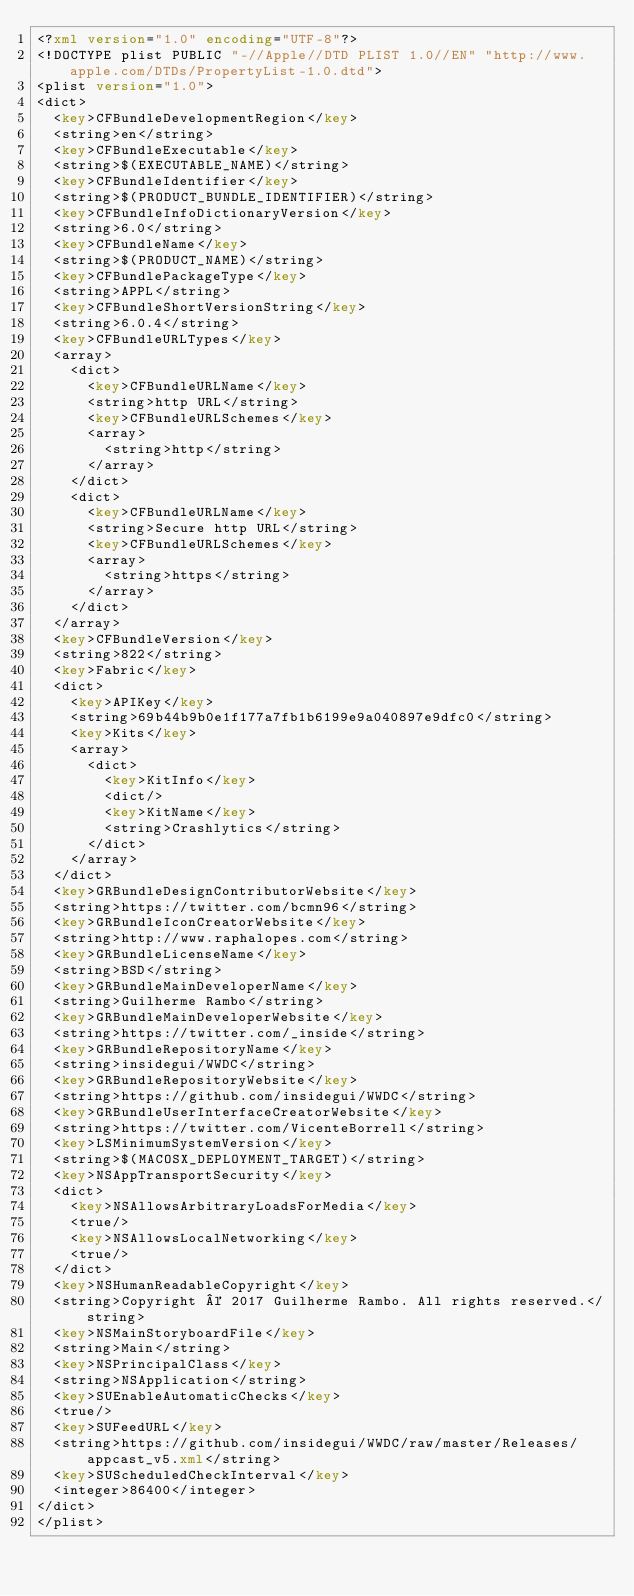<code> <loc_0><loc_0><loc_500><loc_500><_XML_><?xml version="1.0" encoding="UTF-8"?>
<!DOCTYPE plist PUBLIC "-//Apple//DTD PLIST 1.0//EN" "http://www.apple.com/DTDs/PropertyList-1.0.dtd">
<plist version="1.0">
<dict>
	<key>CFBundleDevelopmentRegion</key>
	<string>en</string>
	<key>CFBundleExecutable</key>
	<string>$(EXECUTABLE_NAME)</string>
	<key>CFBundleIdentifier</key>
	<string>$(PRODUCT_BUNDLE_IDENTIFIER)</string>
	<key>CFBundleInfoDictionaryVersion</key>
	<string>6.0</string>
	<key>CFBundleName</key>
	<string>$(PRODUCT_NAME)</string>
	<key>CFBundlePackageType</key>
	<string>APPL</string>
	<key>CFBundleShortVersionString</key>
	<string>6.0.4</string>
	<key>CFBundleURLTypes</key>
	<array>
		<dict>
			<key>CFBundleURLName</key>
			<string>http URL</string>
			<key>CFBundleURLSchemes</key>
			<array>
				<string>http</string>
			</array>
		</dict>
		<dict>
			<key>CFBundleURLName</key>
			<string>Secure http URL</string>
			<key>CFBundleURLSchemes</key>
			<array>
				<string>https</string>
			</array>
		</dict>
	</array>
	<key>CFBundleVersion</key>
	<string>822</string>
	<key>Fabric</key>
	<dict>
		<key>APIKey</key>
		<string>69b44b9b0e1f177a7fb1b6199e9a040897e9dfc0</string>
		<key>Kits</key>
		<array>
			<dict>
				<key>KitInfo</key>
				<dict/>
				<key>KitName</key>
				<string>Crashlytics</string>
			</dict>
		</array>
	</dict>
	<key>GRBundleDesignContributorWebsite</key>
	<string>https://twitter.com/bcmn96</string>
	<key>GRBundleIconCreatorWebsite</key>
	<string>http://www.raphalopes.com</string>
	<key>GRBundleLicenseName</key>
	<string>BSD</string>
	<key>GRBundleMainDeveloperName</key>
	<string>Guilherme Rambo</string>
	<key>GRBundleMainDeveloperWebsite</key>
	<string>https://twitter.com/_inside</string>
	<key>GRBundleRepositoryName</key>
	<string>insidegui/WWDC</string>
	<key>GRBundleRepositoryWebsite</key>
	<string>https://github.com/insidegui/WWDC</string>
	<key>GRBundleUserInterfaceCreatorWebsite</key>
	<string>https://twitter.com/VicenteBorrell</string>
	<key>LSMinimumSystemVersion</key>
	<string>$(MACOSX_DEPLOYMENT_TARGET)</string>
	<key>NSAppTransportSecurity</key>
	<dict>
		<key>NSAllowsArbitraryLoadsForMedia</key>
		<true/>
		<key>NSAllowsLocalNetworking</key>
		<true/>
	</dict>
	<key>NSHumanReadableCopyright</key>
	<string>Copyright © 2017 Guilherme Rambo. All rights reserved.</string>
	<key>NSMainStoryboardFile</key>
	<string>Main</string>
	<key>NSPrincipalClass</key>
	<string>NSApplication</string>
	<key>SUEnableAutomaticChecks</key>
	<true/>
	<key>SUFeedURL</key>
	<string>https://github.com/insidegui/WWDC/raw/master/Releases/appcast_v5.xml</string>
	<key>SUScheduledCheckInterval</key>
	<integer>86400</integer>
</dict>
</plist>
</code> 